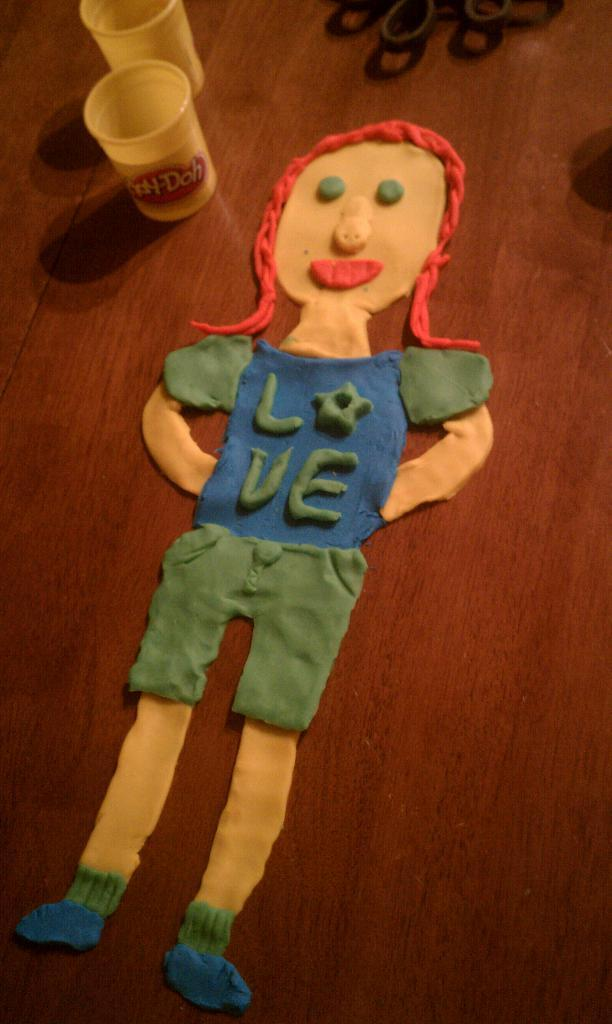Who is present in the image? There is a girl in the image. What object can be seen near the girl? There is a glass in the image. What type of material is the wooden object made of? The wooden object in the image is made of wood. What type of mint can be seen growing near the girl in the image? There is no mint present in the image. What type of bread is the girl holding in the image? There is no bread present in the image. 